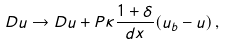<formula> <loc_0><loc_0><loc_500><loc_500>D u \rightarrow D u + P \kappa \frac { 1 + \delta } { d x } ( u _ { b } - u ) \, ,</formula> 